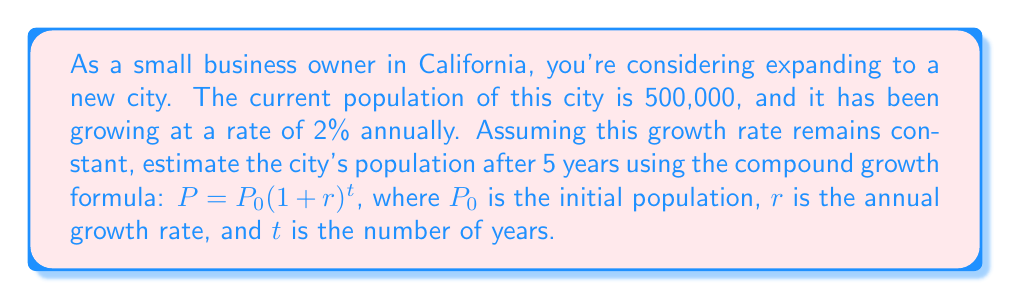Can you answer this question? Let's break this down step-by-step:

1. Identify the given information:
   $P_0 = 500,000$ (initial population)
   $r = 2\% = 0.02$ (annual growth rate)
   $t = 5$ years

2. Use the compound growth formula:
   $P = P_0(1 + r)^t$

3. Substitute the values:
   $P = 500,000(1 + 0.02)^5$

4. Simplify the expression inside the parentheses:
   $P = 500,000(1.02)^5$

5. Calculate $(1.02)^5$:
   $(1.02)^5 \approx 1.1040808032$

6. Multiply the result by the initial population:
   $P = 500,000 \times 1.1040808032 \approx 552,040.4016$

7. Round to the nearest whole number (as we're dealing with population):
   $P \approx 552,040$
Answer: 552,040 